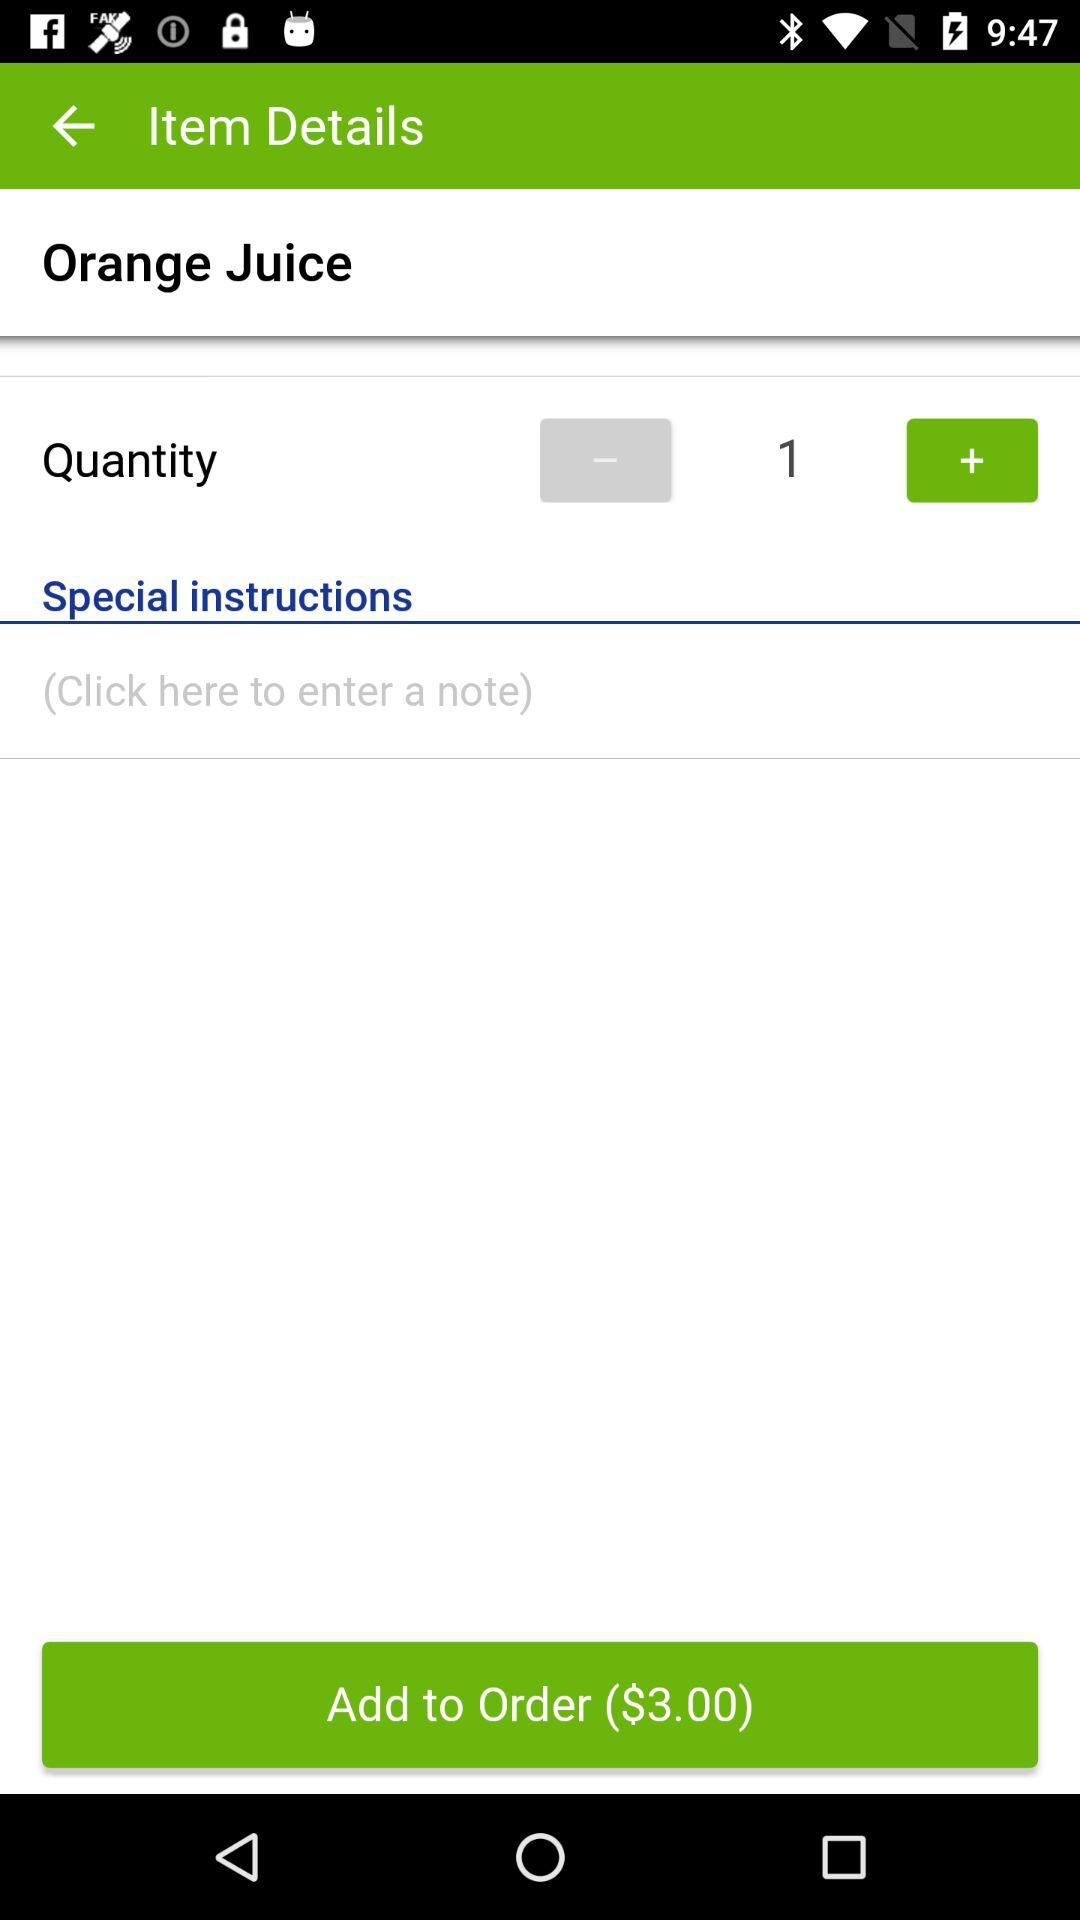How many Orange Juices are in the order?
Answer the question using a single word or phrase. 1 